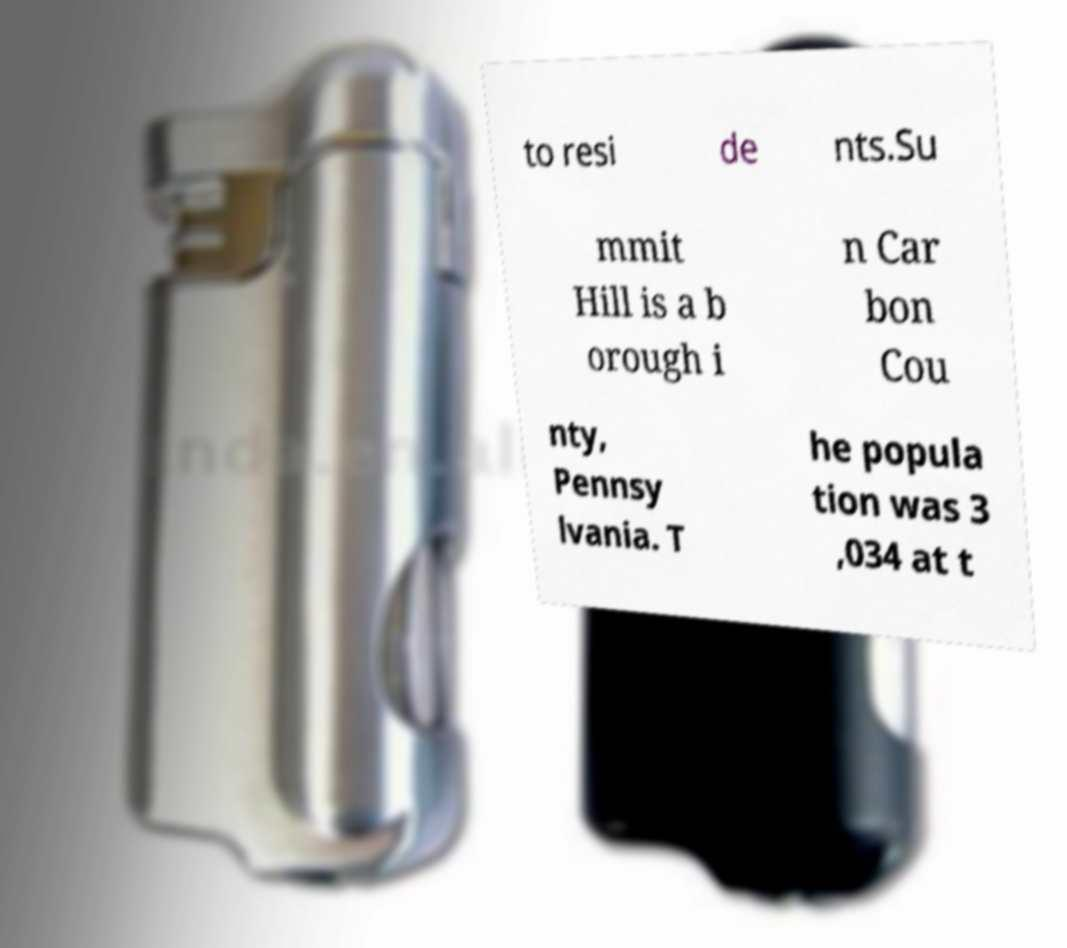I need the written content from this picture converted into text. Can you do that? to resi de nts.Su mmit Hill is a b orough i n Car bon Cou nty, Pennsy lvania. T he popula tion was 3 ,034 at t 